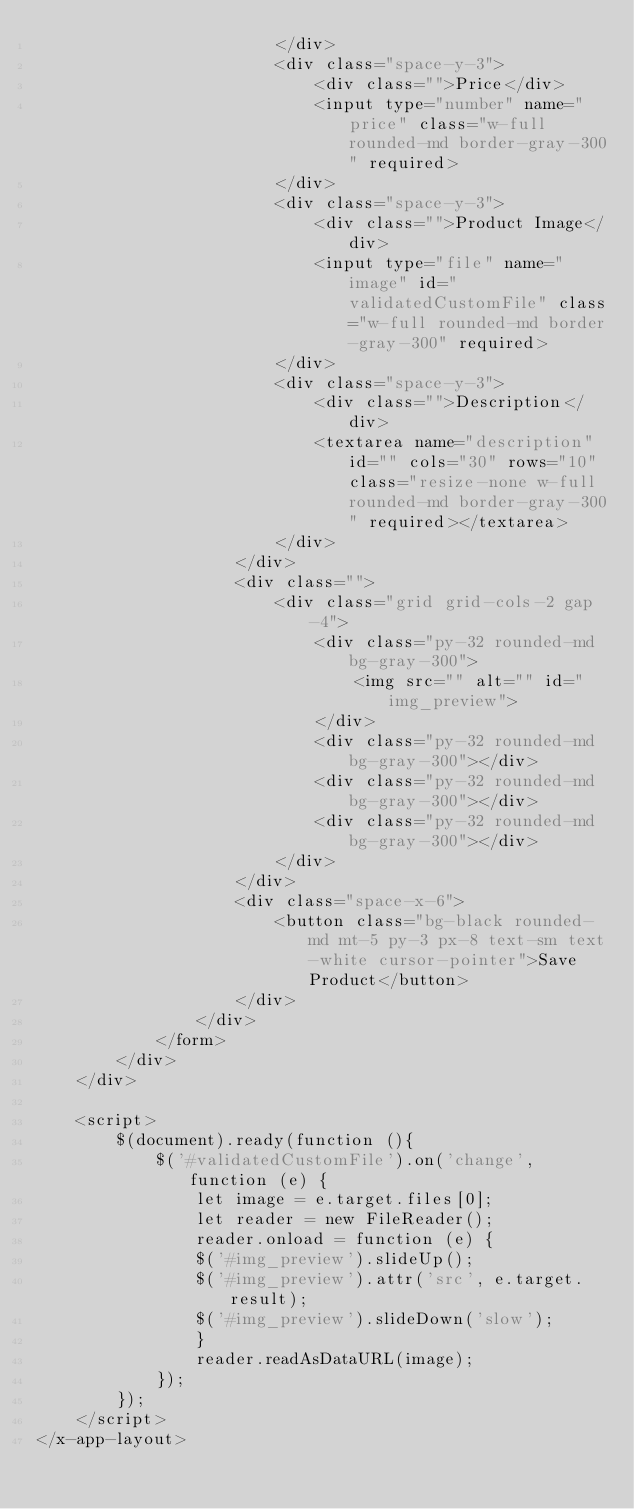<code> <loc_0><loc_0><loc_500><loc_500><_PHP_>                        </div>
                        <div class="space-y-3">
                            <div class="">Price</div>
                            <input type="number" name="price" class="w-full rounded-md border-gray-300" required>
                        </div>
                        <div class="space-y-3">
                            <div class="">Product Image</div>
                            <input type="file" name="image" id="validatedCustomFile" class="w-full rounded-md border-gray-300" required>
                        </div>
                        <div class="space-y-3">
                            <div class="">Description</div>
                            <textarea name="description" id="" cols="30" rows="10" class="resize-none w-full rounded-md border-gray-300" required></textarea>
                        </div>
                    </div>
                    <div class="">
                        <div class="grid grid-cols-2 gap-4">
                            <div class="py-32 rounded-md bg-gray-300">
                                <img src="" alt="" id="img_preview">
                            </div>
                            <div class="py-32 rounded-md bg-gray-300"></div>
                            <div class="py-32 rounded-md bg-gray-300"></div>
                            <div class="py-32 rounded-md bg-gray-300"></div>
                        </div>
                    </div>
                    <div class="space-x-6">
                        <button class="bg-black rounded-md mt-5 py-3 px-8 text-sm text-white cursor-pointer">Save Product</button>
                    </div>
                </div>
            </form>
        </div>
    </div>

    <script>
        $(document).ready(function (){
            $('#validatedCustomFile').on('change', function (e) {
                let image = e.target.files[0];
                let reader = new FileReader();
                reader.onload = function (e) {
                $('#img_preview').slideUp();
                $('#img_preview').attr('src', e.target.result);
                $('#img_preview').slideDown('slow');
                }
                reader.readAsDataURL(image);
            });
        });
    </script>
</x-app-layout>
</code> 